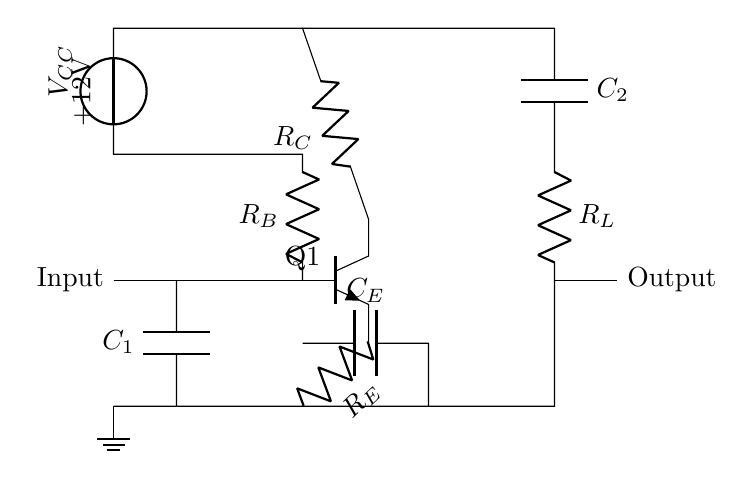What is the type of the transistor in the circuit? The transistor is labeled as "Q1" and is shown as an NPN type. In circuit diagrams, the symbol used represents NPN transistors with a specific arrangement of the collector, base, and emitter connections. Since it’s explicitly marked as an NPN, we can determine its type.
Answer: NPN What is the function of capacitor C1? Capacitor C1 is connected at the input and serves as a coupling capacitor, allowing AC signals to pass through while blocking DC components. This is a common practice in audio applications to prevent DC voltage from affecting subsequent stages.
Answer: Coupling What is the purpose of resistor R_E in this circuit? Resistor R_E is connected to the emitter of the transistor and helps stabilize the transistor's operating point by providing negative feedback. This feedback ensures more consistent performance by reducing variations in gain due to temperature and supply voltage changes.
Answer: Stabilization What is the output voltage labeled in the circuit? The output voltage is not explicitly labeled in terms of numerical value; however, it is derived from the power supply of +12V and filtered through capacitors and resistors. It typically would be a lower voltage related to the audio signal, and no specific value is given in the diagram.
Answer: Not specified How many capacitors are there in this circuit? There are two capacitors shown in the circuit diagram, C1 at the input and C2 at the output. Each plays different roles to couple signals and filter outputs, but both are essential for the amplifier's function.
Answer: Two What does the label +12V represent in the circuit? The label +12V indicates the positive supply voltage for the circuit, providing the necessary power for the transistor and related components to function. This value is fundamental for amplifier operation to ensure proper biasing of the transistor.
Answer: Positive supply voltage 